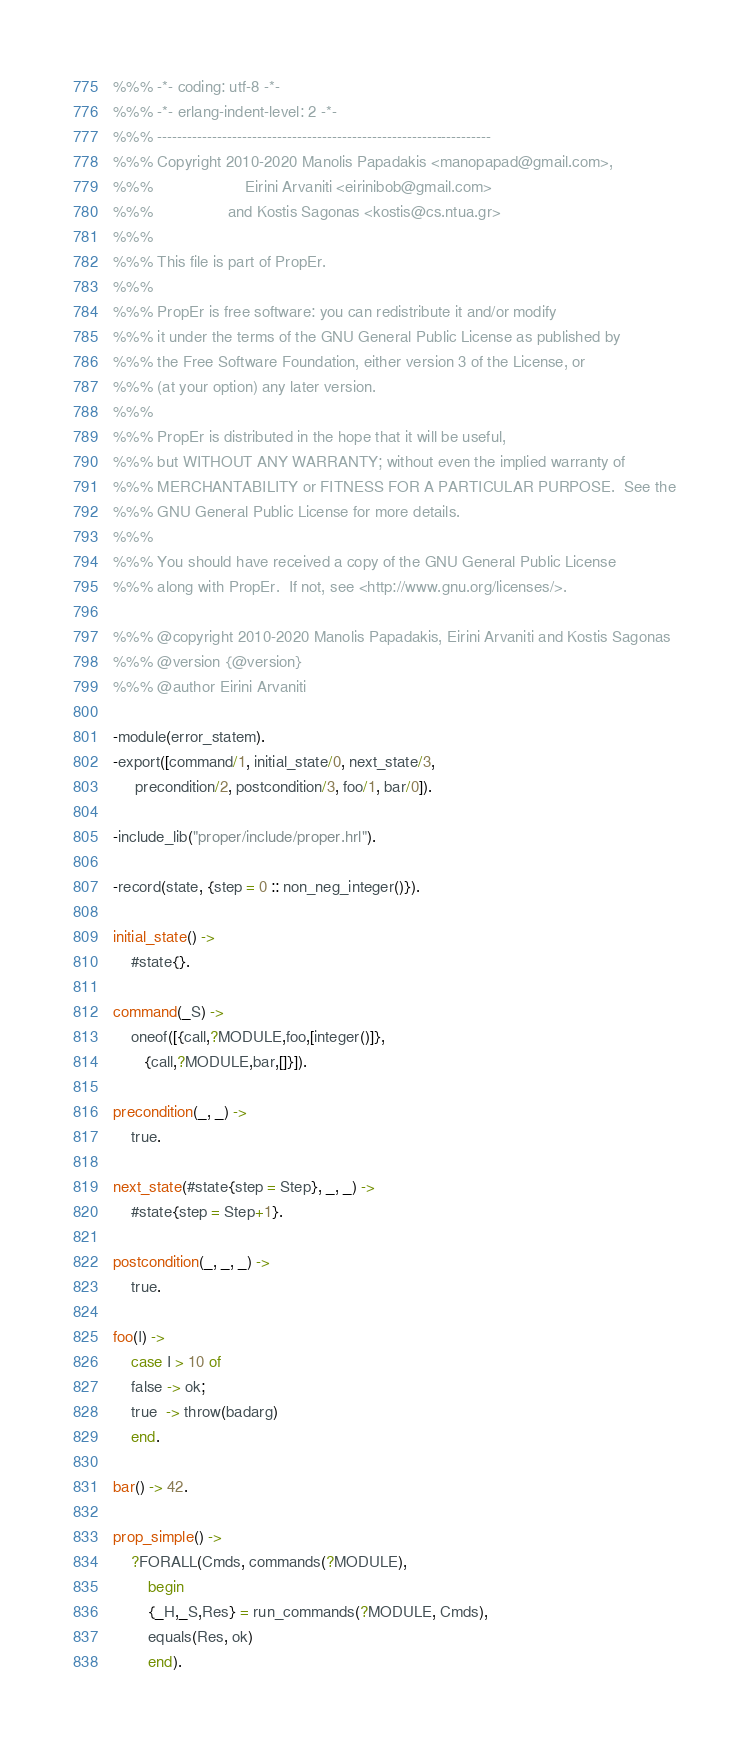<code> <loc_0><loc_0><loc_500><loc_500><_Erlang_>%%% -*- coding: utf-8 -*-
%%% -*- erlang-indent-level: 2 -*-
%%% -------------------------------------------------------------------
%%% Copyright 2010-2020 Manolis Papadakis <manopapad@gmail.com>,
%%%                     Eirini Arvaniti <eirinibob@gmail.com>
%%%                 and Kostis Sagonas <kostis@cs.ntua.gr>
%%%
%%% This file is part of PropEr.
%%%
%%% PropEr is free software: you can redistribute it and/or modify
%%% it under the terms of the GNU General Public License as published by
%%% the Free Software Foundation, either version 3 of the License, or
%%% (at your option) any later version.
%%%
%%% PropEr is distributed in the hope that it will be useful,
%%% but WITHOUT ANY WARRANTY; without even the implied warranty of
%%% MERCHANTABILITY or FITNESS FOR A PARTICULAR PURPOSE.  See the
%%% GNU General Public License for more details.
%%%
%%% You should have received a copy of the GNU General Public License
%%% along with PropEr.  If not, see <http://www.gnu.org/licenses/>.

%%% @copyright 2010-2020 Manolis Papadakis, Eirini Arvaniti and Kostis Sagonas
%%% @version {@version}
%%% @author Eirini Arvaniti

-module(error_statem).
-export([command/1, initial_state/0, next_state/3,
	 precondition/2, postcondition/3, foo/1, bar/0]).

-include_lib("proper/include/proper.hrl").

-record(state, {step = 0 :: non_neg_integer()}).

initial_state() ->
    #state{}.

command(_S) ->
    oneof([{call,?MODULE,foo,[integer()]},
	   {call,?MODULE,bar,[]}]).

precondition(_, _) ->
    true.

next_state(#state{step = Step}, _, _) ->
    #state{step = Step+1}.

postcondition(_, _, _) ->
    true.

foo(I) ->
    case I > 10 of
	false -> ok;
	true  -> throw(badarg)
    end.

bar() -> 42.

prop_simple() ->
    ?FORALL(Cmds, commands(?MODULE),
	    begin
		{_H,_S,Res} = run_commands(?MODULE, Cmds),
		equals(Res, ok)
	    end).
</code> 